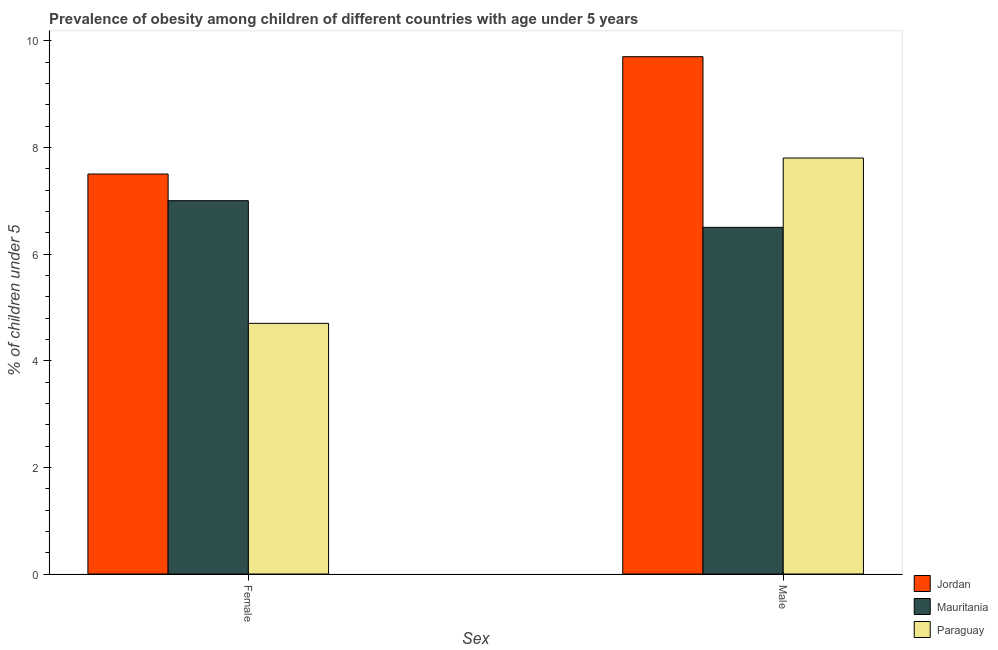How many different coloured bars are there?
Offer a very short reply. 3. Are the number of bars on each tick of the X-axis equal?
Ensure brevity in your answer.  Yes. How many bars are there on the 1st tick from the left?
Make the answer very short. 3. What is the label of the 2nd group of bars from the left?
Your answer should be compact. Male. What is the percentage of obese male children in Paraguay?
Make the answer very short. 7.8. Across all countries, what is the maximum percentage of obese female children?
Your answer should be very brief. 7.5. Across all countries, what is the minimum percentage of obese female children?
Your response must be concise. 4.7. In which country was the percentage of obese female children maximum?
Offer a very short reply. Jordan. In which country was the percentage of obese female children minimum?
Ensure brevity in your answer.  Paraguay. What is the total percentage of obese male children in the graph?
Give a very brief answer. 24. What is the difference between the percentage of obese female children in Mauritania and that in Paraguay?
Your answer should be very brief. 2.3. What is the difference between the percentage of obese male children in Mauritania and the percentage of obese female children in Paraguay?
Your answer should be compact. 1.8. What is the average percentage of obese female children per country?
Your answer should be very brief. 6.4. What is the ratio of the percentage of obese female children in Mauritania to that in Jordan?
Make the answer very short. 0.93. In how many countries, is the percentage of obese male children greater than the average percentage of obese male children taken over all countries?
Keep it short and to the point. 1. What does the 1st bar from the left in Female represents?
Your response must be concise. Jordan. What does the 2nd bar from the right in Male represents?
Provide a short and direct response. Mauritania. Are all the bars in the graph horizontal?
Provide a succinct answer. No. How many countries are there in the graph?
Give a very brief answer. 3. Are the values on the major ticks of Y-axis written in scientific E-notation?
Your answer should be compact. No. Where does the legend appear in the graph?
Offer a terse response. Bottom right. How many legend labels are there?
Provide a short and direct response. 3. How are the legend labels stacked?
Ensure brevity in your answer.  Vertical. What is the title of the graph?
Offer a very short reply. Prevalence of obesity among children of different countries with age under 5 years. What is the label or title of the X-axis?
Provide a short and direct response. Sex. What is the label or title of the Y-axis?
Your answer should be compact.  % of children under 5. What is the  % of children under 5 in Mauritania in Female?
Make the answer very short. 7. What is the  % of children under 5 in Paraguay in Female?
Your response must be concise. 4.7. What is the  % of children under 5 of Jordan in Male?
Offer a very short reply. 9.7. What is the  % of children under 5 of Mauritania in Male?
Your answer should be compact. 6.5. What is the  % of children under 5 in Paraguay in Male?
Provide a succinct answer. 7.8. Across all Sex, what is the maximum  % of children under 5 of Jordan?
Provide a short and direct response. 9.7. Across all Sex, what is the maximum  % of children under 5 in Paraguay?
Offer a terse response. 7.8. Across all Sex, what is the minimum  % of children under 5 of Paraguay?
Provide a short and direct response. 4.7. What is the total  % of children under 5 in Mauritania in the graph?
Ensure brevity in your answer.  13.5. What is the difference between the  % of children under 5 in Jordan in Female and that in Male?
Ensure brevity in your answer.  -2.2. What is the difference between the  % of children under 5 in Paraguay in Female and that in Male?
Ensure brevity in your answer.  -3.1. What is the difference between the  % of children under 5 in Jordan in Female and the  % of children under 5 in Mauritania in Male?
Your response must be concise. 1. What is the difference between the  % of children under 5 in Mauritania in Female and the  % of children under 5 in Paraguay in Male?
Give a very brief answer. -0.8. What is the average  % of children under 5 of Mauritania per Sex?
Keep it short and to the point. 6.75. What is the average  % of children under 5 in Paraguay per Sex?
Give a very brief answer. 6.25. What is the difference between the  % of children under 5 of Jordan and  % of children under 5 of Paraguay in Female?
Your answer should be very brief. 2.8. What is the difference between the  % of children under 5 of Mauritania and  % of children under 5 of Paraguay in Female?
Make the answer very short. 2.3. What is the difference between the  % of children under 5 in Jordan and  % of children under 5 in Mauritania in Male?
Offer a very short reply. 3.2. What is the ratio of the  % of children under 5 in Jordan in Female to that in Male?
Ensure brevity in your answer.  0.77. What is the ratio of the  % of children under 5 of Mauritania in Female to that in Male?
Keep it short and to the point. 1.08. What is the ratio of the  % of children under 5 of Paraguay in Female to that in Male?
Your answer should be very brief. 0.6. What is the difference between the highest and the second highest  % of children under 5 of Jordan?
Your answer should be very brief. 2.2. What is the difference between the highest and the second highest  % of children under 5 in Mauritania?
Provide a short and direct response. 0.5. What is the difference between the highest and the second highest  % of children under 5 of Paraguay?
Provide a succinct answer. 3.1. What is the difference between the highest and the lowest  % of children under 5 in Mauritania?
Offer a terse response. 0.5. 